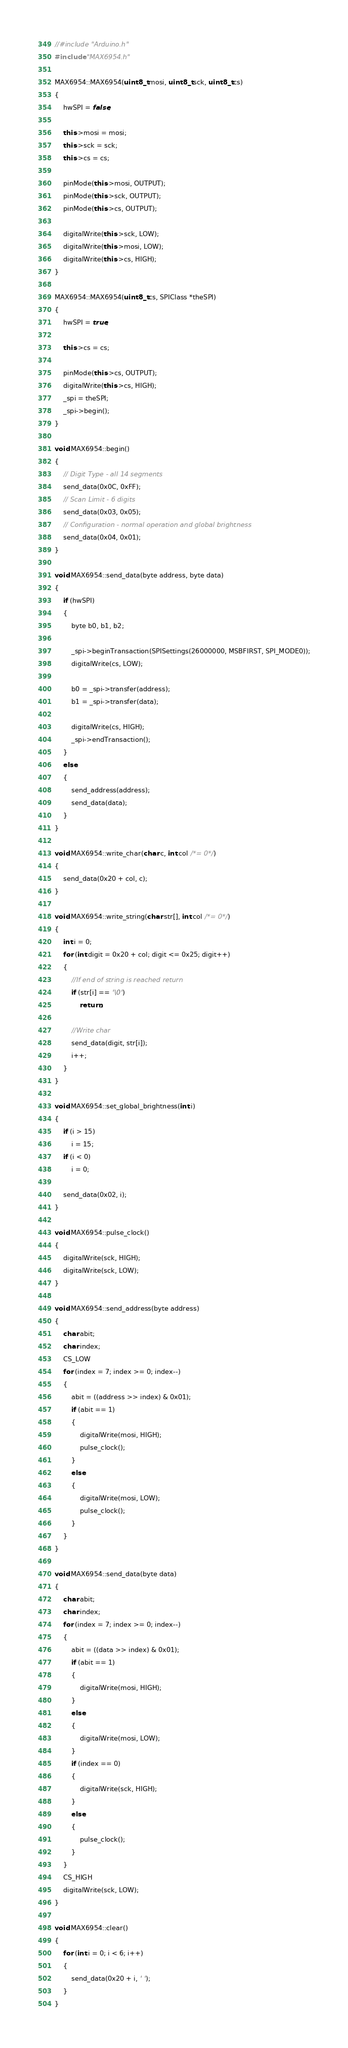<code> <loc_0><loc_0><loc_500><loc_500><_C++_>//#include "Arduino.h"
#include "MAX6954.h"

MAX6954::MAX6954(uint8_t mosi, uint8_t sck, uint8_t cs)
{
    hwSPI = false;

    this->mosi = mosi;
    this->sck = sck;
    this->cs = cs;

    pinMode(this->mosi, OUTPUT);
    pinMode(this->sck, OUTPUT);
    pinMode(this->cs, OUTPUT);

    digitalWrite(this->sck, LOW);
    digitalWrite(this->mosi, LOW);
    digitalWrite(this->cs, HIGH);
}

MAX6954::MAX6954(uint8_t cs, SPIClass *theSPI)
{
    hwSPI = true;

    this->cs = cs;

    pinMode(this->cs, OUTPUT);
    digitalWrite(this->cs, HIGH);
    _spi = theSPI;
    _spi->begin();
}

void MAX6954::begin()
{
    // Digit Type - all 14 segments
    send_data(0x0C, 0xFF);
    // Scan Limit - 6 digits
    send_data(0x03, 0x05);
    // Configuration - normal operation and global brightness
    send_data(0x04, 0x01);
}

void MAX6954::send_data(byte address, byte data)
{
    if (hwSPI)
    {
        byte b0, b1, b2;

        _spi->beginTransaction(SPISettings(26000000, MSBFIRST, SPI_MODE0));
        digitalWrite(cs, LOW);

        b0 = _spi->transfer(address);
        b1 = _spi->transfer(data);

        digitalWrite(cs, HIGH);
        _spi->endTransaction();
    }
    else
    {
        send_address(address);
        send_data(data);
    }
}

void MAX6954::write_char(char c, int col /*= 0*/)
{
    send_data(0x20 + col, c);
}

void MAX6954::write_string(char str[], int col /*= 0*/)
{
    int i = 0;
    for (int digit = 0x20 + col; digit <= 0x25; digit++)
    {
        //If end of string is reached return
        if (str[i] == '\0')
            return;

        //Write char
        send_data(digit, str[i]);
        i++;
    }
}

void MAX6954::set_global_brightness(int i)
{
    if (i > 15)
        i = 15;
    if (i < 0)
        i = 0;

    send_data(0x02, i);
}

void MAX6954::pulse_clock()
{
    digitalWrite(sck, HIGH);
    digitalWrite(sck, LOW);
}

void MAX6954::send_address(byte address)
{
    char abit;
    char index;
    CS_LOW
    for (index = 7; index >= 0; index--)
    {
        abit = ((address >> index) & 0x01);
        if (abit == 1)
        {
            digitalWrite(mosi, HIGH);
            pulse_clock();
        }
        else
        {
            digitalWrite(mosi, LOW);
            pulse_clock();
        }
    }
}

void MAX6954::send_data(byte data)
{
    char abit;
    char index;
    for (index = 7; index >= 0; index--)
    {
        abit = ((data >> index) & 0x01);
        if (abit == 1)
        {
            digitalWrite(mosi, HIGH);
        }
        else
        {
            digitalWrite(mosi, LOW);
        }
        if (index == 0)
        {
            digitalWrite(sck, HIGH);
        }
        else
        {
            pulse_clock();
        }
    }
    CS_HIGH
    digitalWrite(sck, LOW);
}

void MAX6954::clear()
{
    for (int i = 0; i < 6; i++)
    {
        send_data(0x20 + i, ' ');
    }
}</code> 